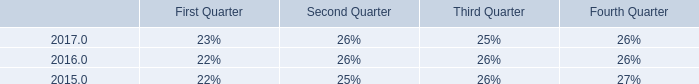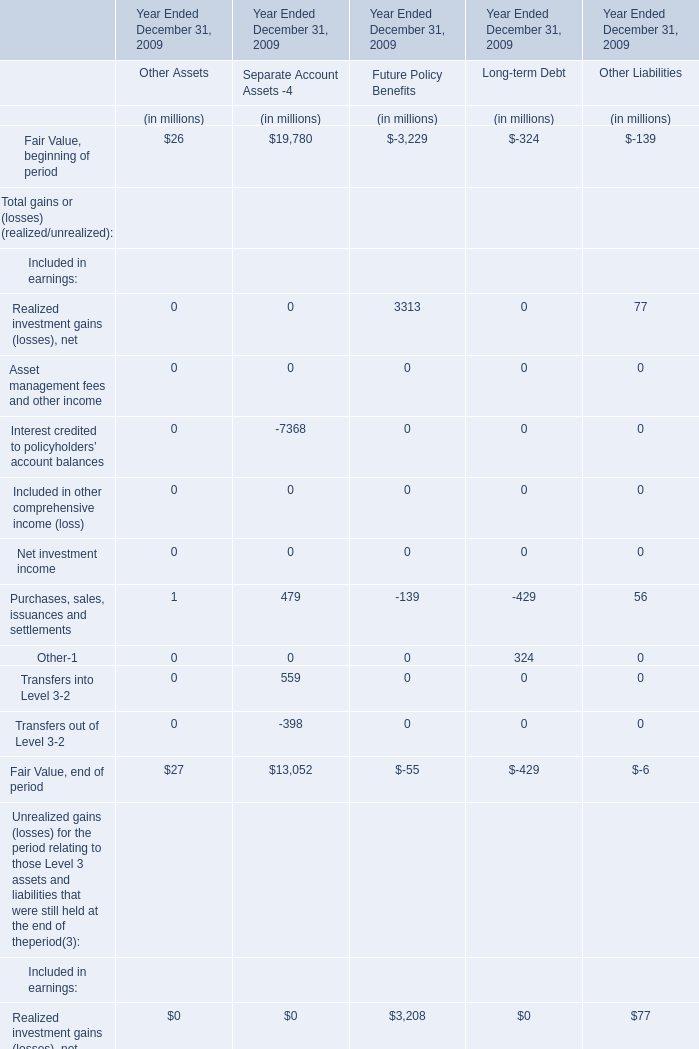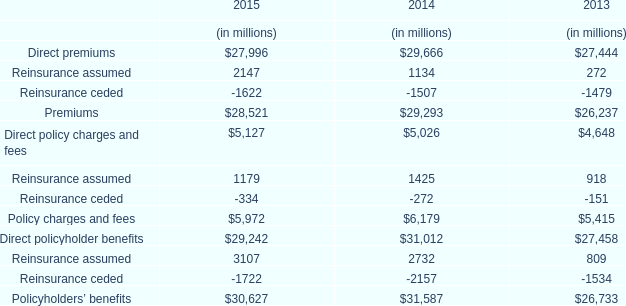considering the years 2016-2017 , what is the average value recorded for reserves for environmental matters , in millions of dollars? 
Computations: ((28.9 + 30.6) / 2)
Answer: 29.75. 